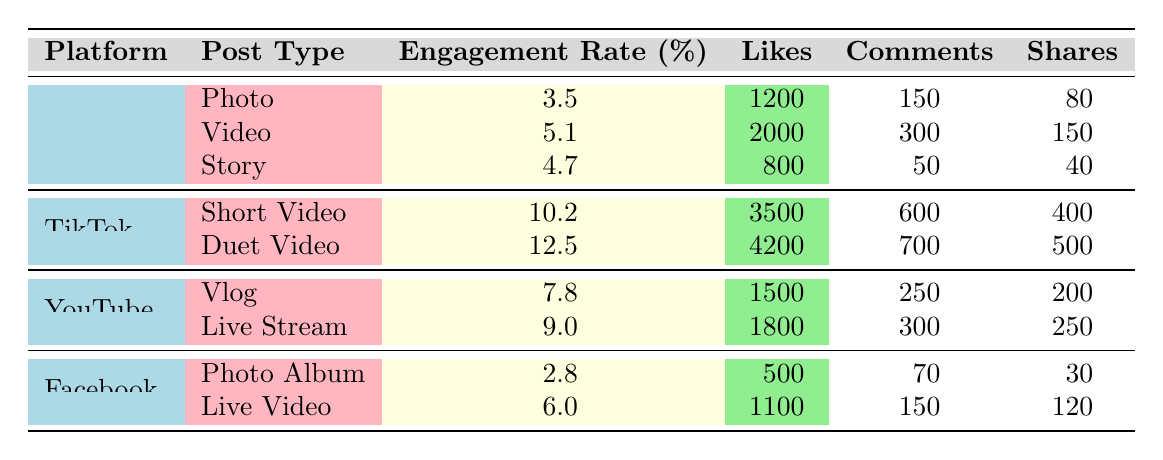What is the highest engagement rate, and which platform and post type does it belong to? The engagement rates of the posts are listed in the table. The highest engagement rate is 12.5%, which belongs to TikTok's Duet Video.
Answer: 12.5%, TikTok, Duet Video How many likes did Instagram videos receive? By looking at the Instagram section, the Likes for Video post type are 2000.
Answer: 2000 Is the engagement rate of Facebook Photo Album higher than that of Instagram Photo? Facebook Photo Album's engagement rate is 2.8%, while Instagram Photo's engagement rate is 3.5%. Therefore, Facebook Photo Album's engagement rate is lower.
Answer: No What is the total number of shares for all TikTok post types? The TikTok post types are Short Video and Duet Video with shares of 400 and 500, respectively. The total is 400 + 500 = 900.
Answer: 900 Which post type has the least number of comments on Instagram? Looking through the Instagram post types, the Story received 50 comments, which is the least compared to Photo (150) and Video (300).
Answer: Story What is the average engagement rate across all platforms? The engagement rates for each post type are 3.5, 5.1, 4.7, 10.2, 12.5, 7.8, 9.0, 2.8, and 6.0. Adding them up gives 61.6, and dividing by 9 (the number of post types) provides an average of 6.84.
Answer: 6.84 Does the YouTube Live Stream have more likes than the Facebook Live Video? YouTube Live Stream has 1800 likes, and Facebook Live Video has 1100 likes. Since 1800 is greater than 1100, the statement is true.
Answer: Yes What is the difference in the number of likes between the TikTok Duet Video and the YouTube Vlog? The TikTok Duet Video received 4200 likes, and the YouTube Vlog received 1500. The difference is 4200 - 1500 = 2700.
Answer: 2700 